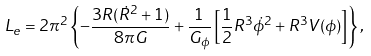<formula> <loc_0><loc_0><loc_500><loc_500>L _ { e } = 2 \pi ^ { 2 } \left \{ - \frac { 3 R ( \dot { R } ^ { 2 } + 1 ) } { 8 \pi G } + \frac { 1 } { G _ { \phi } } \left [ \frac { 1 } { 2 } R ^ { 3 } \dot { \phi } ^ { 2 } + R ^ { 3 } V ( \phi ) \right ] \right \} ,</formula> 